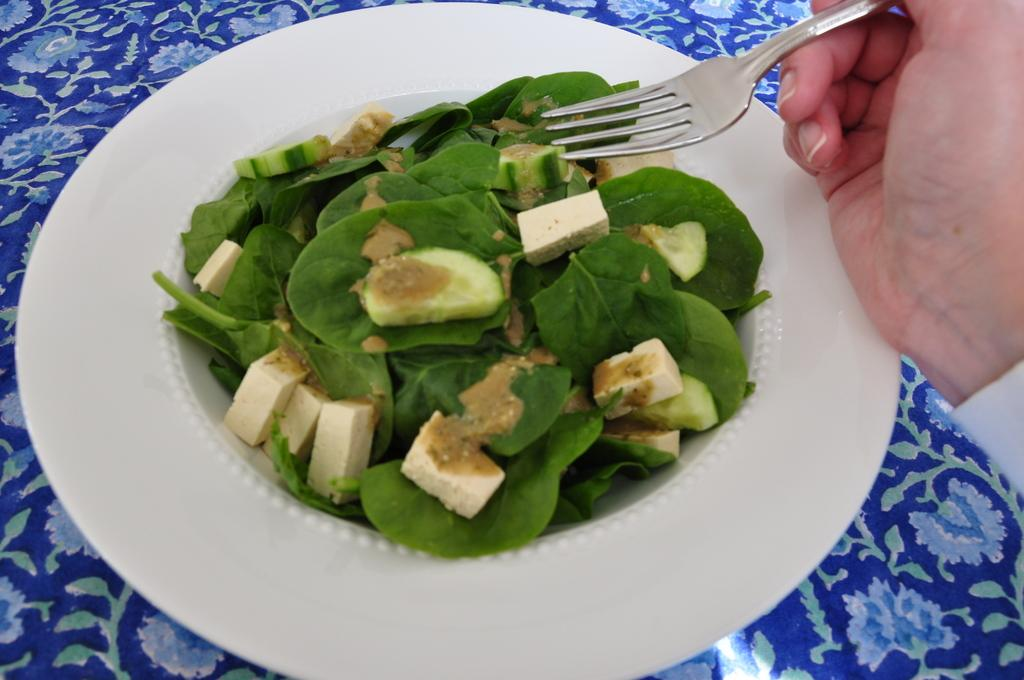What is on the table in the image? There is a plate on the table in the image. What is on the plate? There is food on the plate, including leafy vegetables. Can you describe the person's hand in the image? A person's hand is visible on the right side of the image, and they are holding a fork. How many sisters are sitting next to the donkey in the image? There is no donkey or sisters present in the image. What type of porter is carrying the food on the plate? There is no porter involved in the image; the food is already on the plate. 